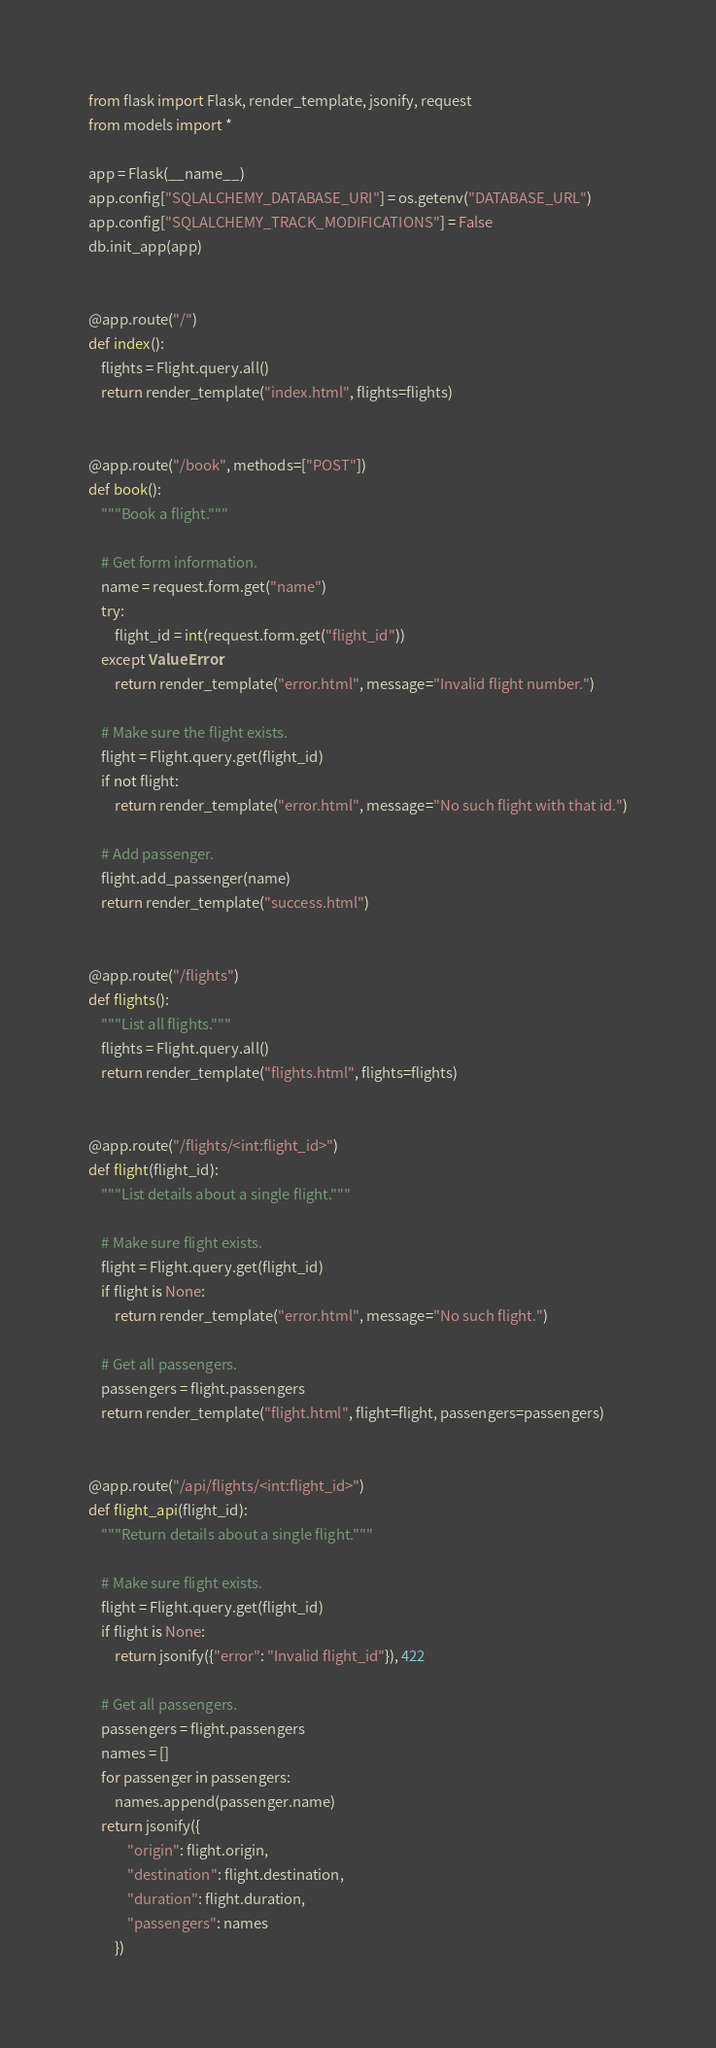Convert code to text. <code><loc_0><loc_0><loc_500><loc_500><_Python_>from flask import Flask, render_template, jsonify, request
from models import *

app = Flask(__name__)
app.config["SQLALCHEMY_DATABASE_URI"] = os.getenv("DATABASE_URL")
app.config["SQLALCHEMY_TRACK_MODIFICATIONS"] = False
db.init_app(app)


@app.route("/")
def index():
    flights = Flight.query.all()
    return render_template("index.html", flights=flights)


@app.route("/book", methods=["POST"])
def book():
    """Book a flight."""

    # Get form information.
    name = request.form.get("name")
    try:
        flight_id = int(request.form.get("flight_id"))
    except ValueError:
        return render_template("error.html", message="Invalid flight number.")

    # Make sure the flight exists.
    flight = Flight.query.get(flight_id)
    if not flight:
        return render_template("error.html", message="No such flight with that id.")

    # Add passenger.
    flight.add_passenger(name)
    return render_template("success.html")


@app.route("/flights")
def flights():
    """List all flights."""
    flights = Flight.query.all()
    return render_template("flights.html", flights=flights)


@app.route("/flights/<int:flight_id>")
def flight(flight_id):
    """List details about a single flight."""

    # Make sure flight exists.
    flight = Flight.query.get(flight_id)
    if flight is None:
        return render_template("error.html", message="No such flight.")

    # Get all passengers.
    passengers = flight.passengers
    return render_template("flight.html", flight=flight, passengers=passengers)


@app.route("/api/flights/<int:flight_id>")
def flight_api(flight_id):
    """Return details about a single flight."""

    # Make sure flight exists.
    flight = Flight.query.get(flight_id)
    if flight is None:
        return jsonify({"error": "Invalid flight_id"}), 422

    # Get all passengers.
    passengers = flight.passengers
    names = []
    for passenger in passengers:
        names.append(passenger.name)
    return jsonify({
            "origin": flight.origin,
            "destination": flight.destination,
            "duration": flight.duration,
            "passengers": names
        })
</code> 